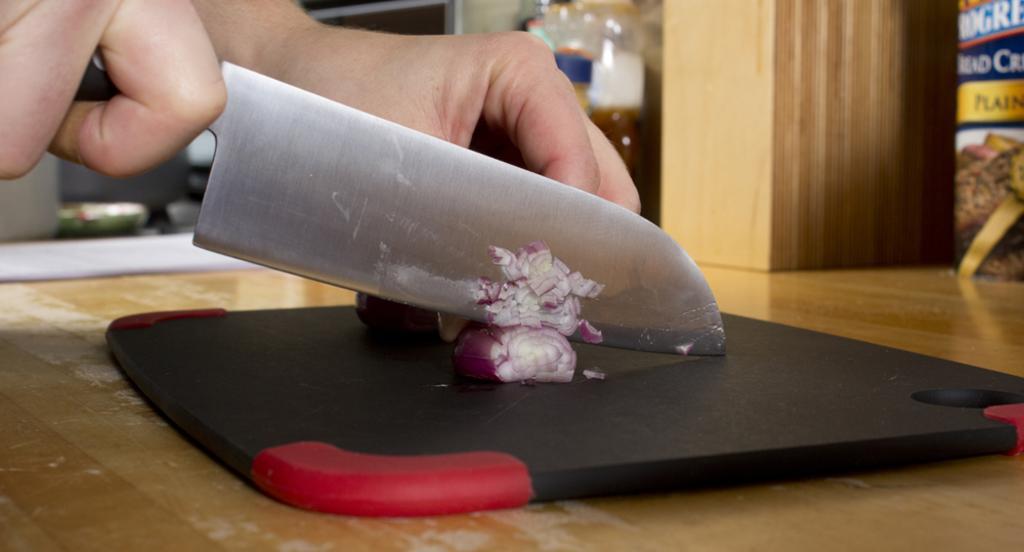In one or two sentences, can you explain what this image depicts? As we can see in the image, there is a human hand. He is holding a knife in his hand and cutting the onions on vegetable cutter. The vegetable cutter is on table. 